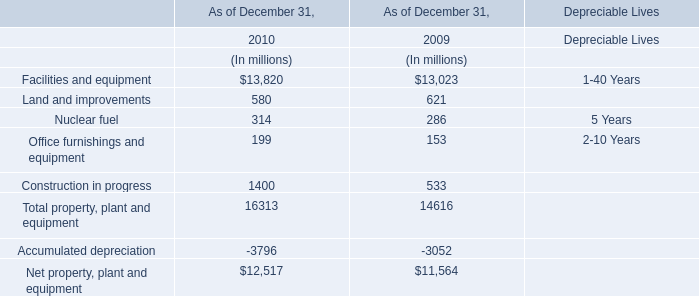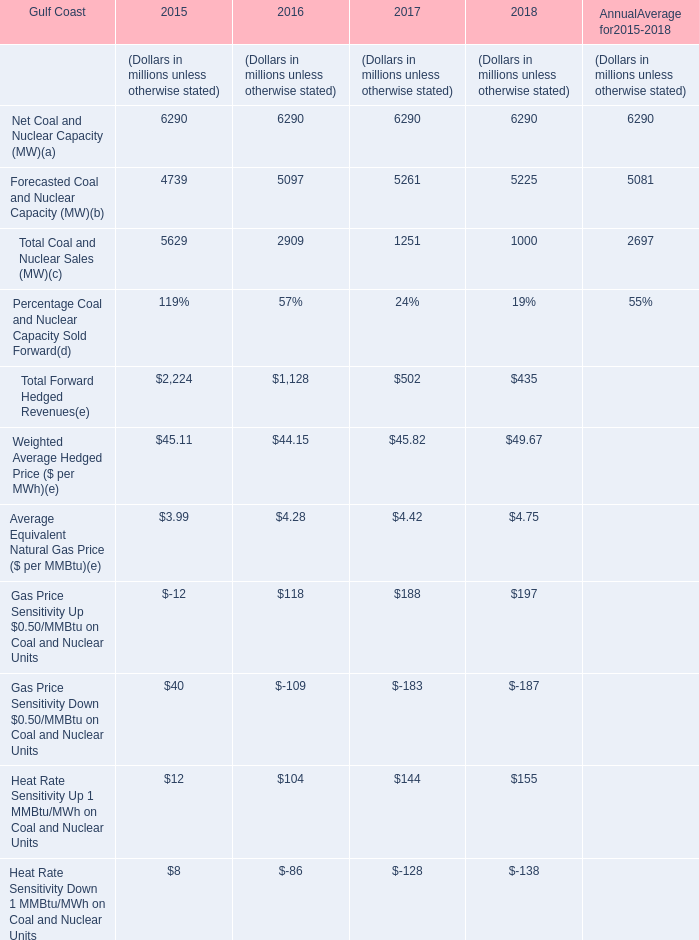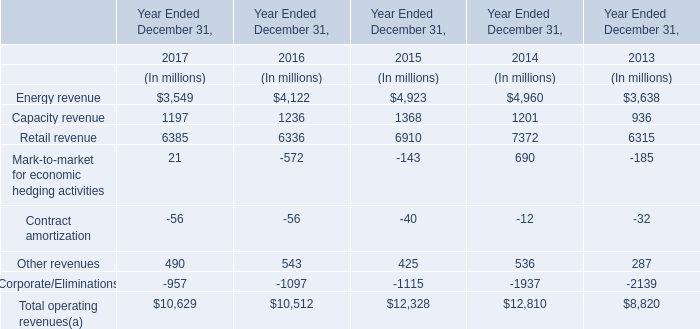In the year with the most Forecasted Coal and Nuclear Capacity (MW), what is the growth rate of Total Forward Hedged Revenues? 
Computations: ((502 - 1128) / 1128)
Answer: -0.55496. 